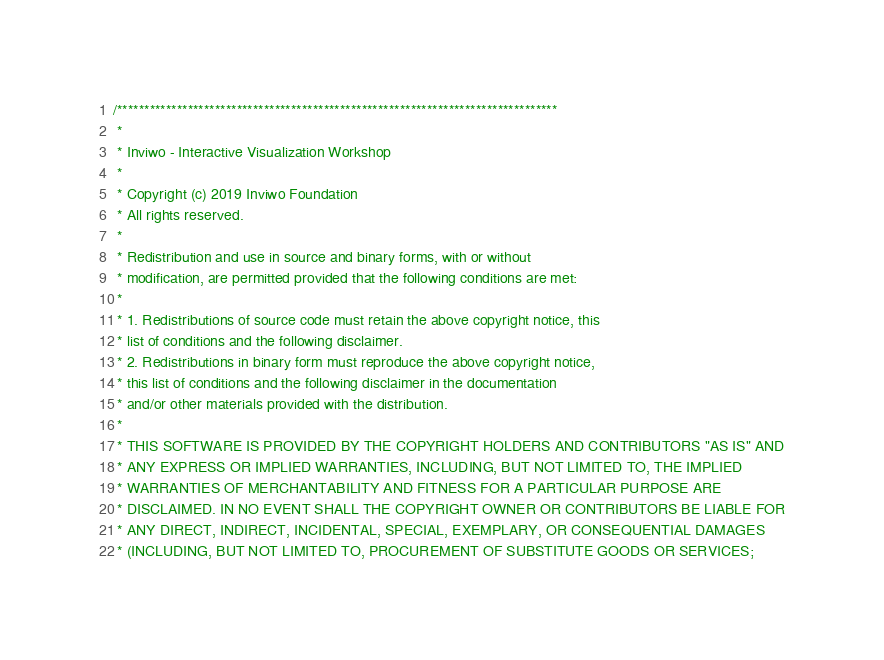Convert code to text. <code><loc_0><loc_0><loc_500><loc_500><_C_>/*********************************************************************************
 *
 * Inviwo - Interactive Visualization Workshop
 *
 * Copyright (c) 2019 Inviwo Foundation
 * All rights reserved.
 *
 * Redistribution and use in source and binary forms, with or without
 * modification, are permitted provided that the following conditions are met:
 *
 * 1. Redistributions of source code must retain the above copyright notice, this
 * list of conditions and the following disclaimer.
 * 2. Redistributions in binary form must reproduce the above copyright notice,
 * this list of conditions and the following disclaimer in the documentation
 * and/or other materials provided with the distribution.
 *
 * THIS SOFTWARE IS PROVIDED BY THE COPYRIGHT HOLDERS AND CONTRIBUTORS "AS IS" AND
 * ANY EXPRESS OR IMPLIED WARRANTIES, INCLUDING, BUT NOT LIMITED TO, THE IMPLIED
 * WARRANTIES OF MERCHANTABILITY AND FITNESS FOR A PARTICULAR PURPOSE ARE
 * DISCLAIMED. IN NO EVENT SHALL THE COPYRIGHT OWNER OR CONTRIBUTORS BE LIABLE FOR
 * ANY DIRECT, INDIRECT, INCIDENTAL, SPECIAL, EXEMPLARY, OR CONSEQUENTIAL DAMAGES
 * (INCLUDING, BUT NOT LIMITED TO, PROCUREMENT OF SUBSTITUTE GOODS OR SERVICES;</code> 